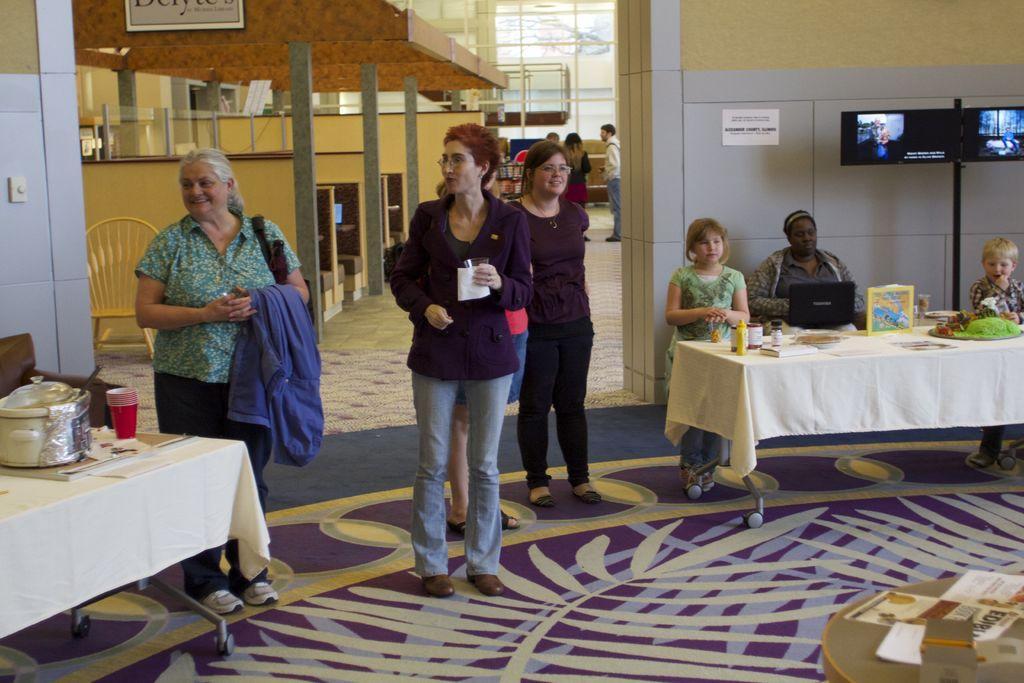Can you describe this image briefly? In the image we can see there are people who are standing and few people are sitting on chair and on the table there is laptop and in vessel there are food items. 